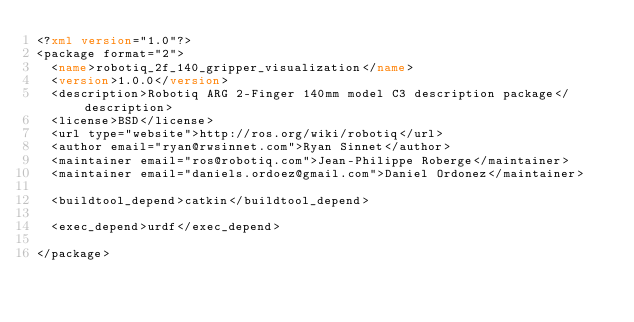<code> <loc_0><loc_0><loc_500><loc_500><_XML_><?xml version="1.0"?>
<package format="2">
  <name>robotiq_2f_140_gripper_visualization</name>
  <version>1.0.0</version>
  <description>Robotiq ARG 2-Finger 140mm model C3 description package</description>
  <license>BSD</license>
  <url type="website">http://ros.org/wiki/robotiq</url>
  <author email="ryan@rwsinnet.com">Ryan Sinnet</author>
  <maintainer email="ros@robotiq.com">Jean-Philippe Roberge</maintainer>
  <maintainer email="daniels.ordoez@gmail.com">Daniel Ordonez</maintainer>

  <buildtool_depend>catkin</buildtool_depend>

  <exec_depend>urdf</exec_depend>

</package>
</code> 